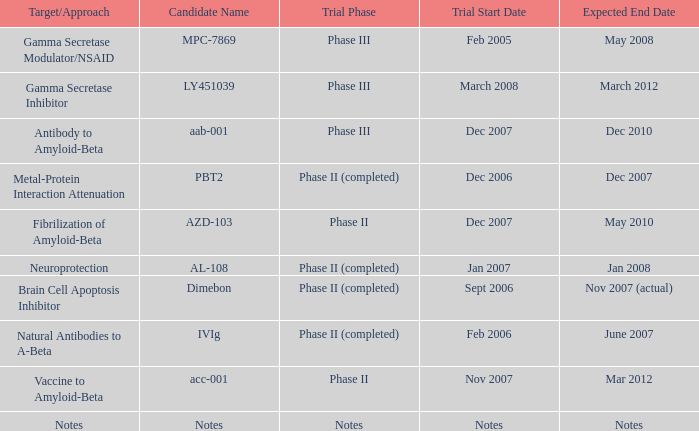When notes is the name of the candidate, what is the commencement date of the trial? Notes. 